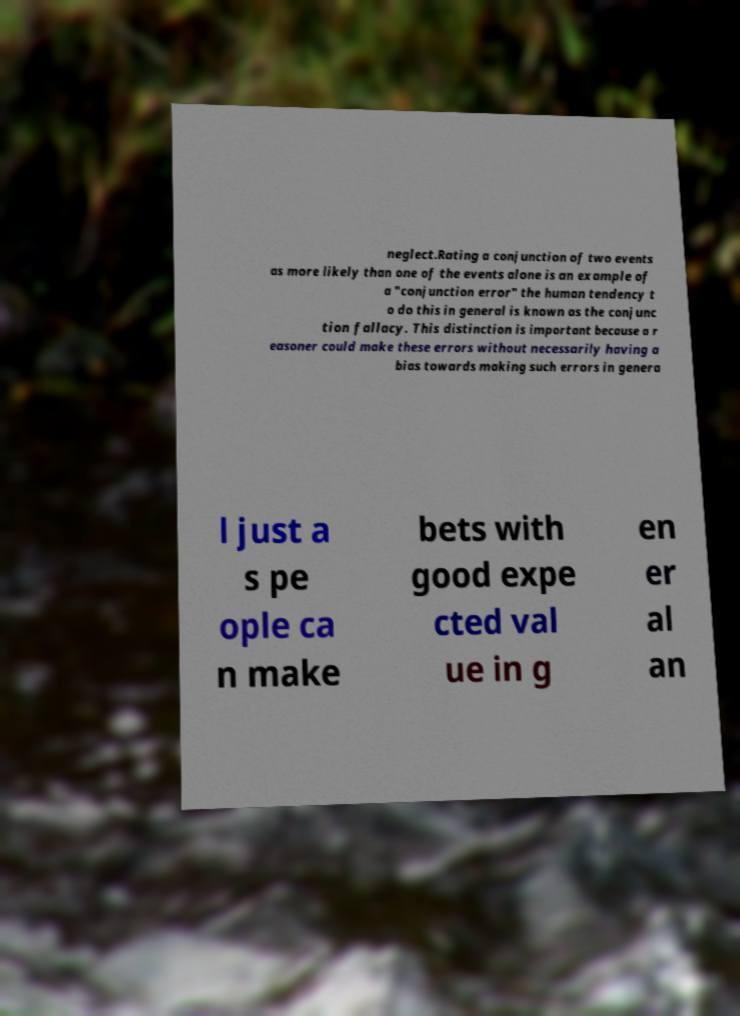Could you extract and type out the text from this image? neglect.Rating a conjunction of two events as more likely than one of the events alone is an example of a "conjunction error" the human tendency t o do this in general is known as the conjunc tion fallacy. This distinction is important because a r easoner could make these errors without necessarily having a bias towards making such errors in genera l just a s pe ople ca n make bets with good expe cted val ue in g en er al an 